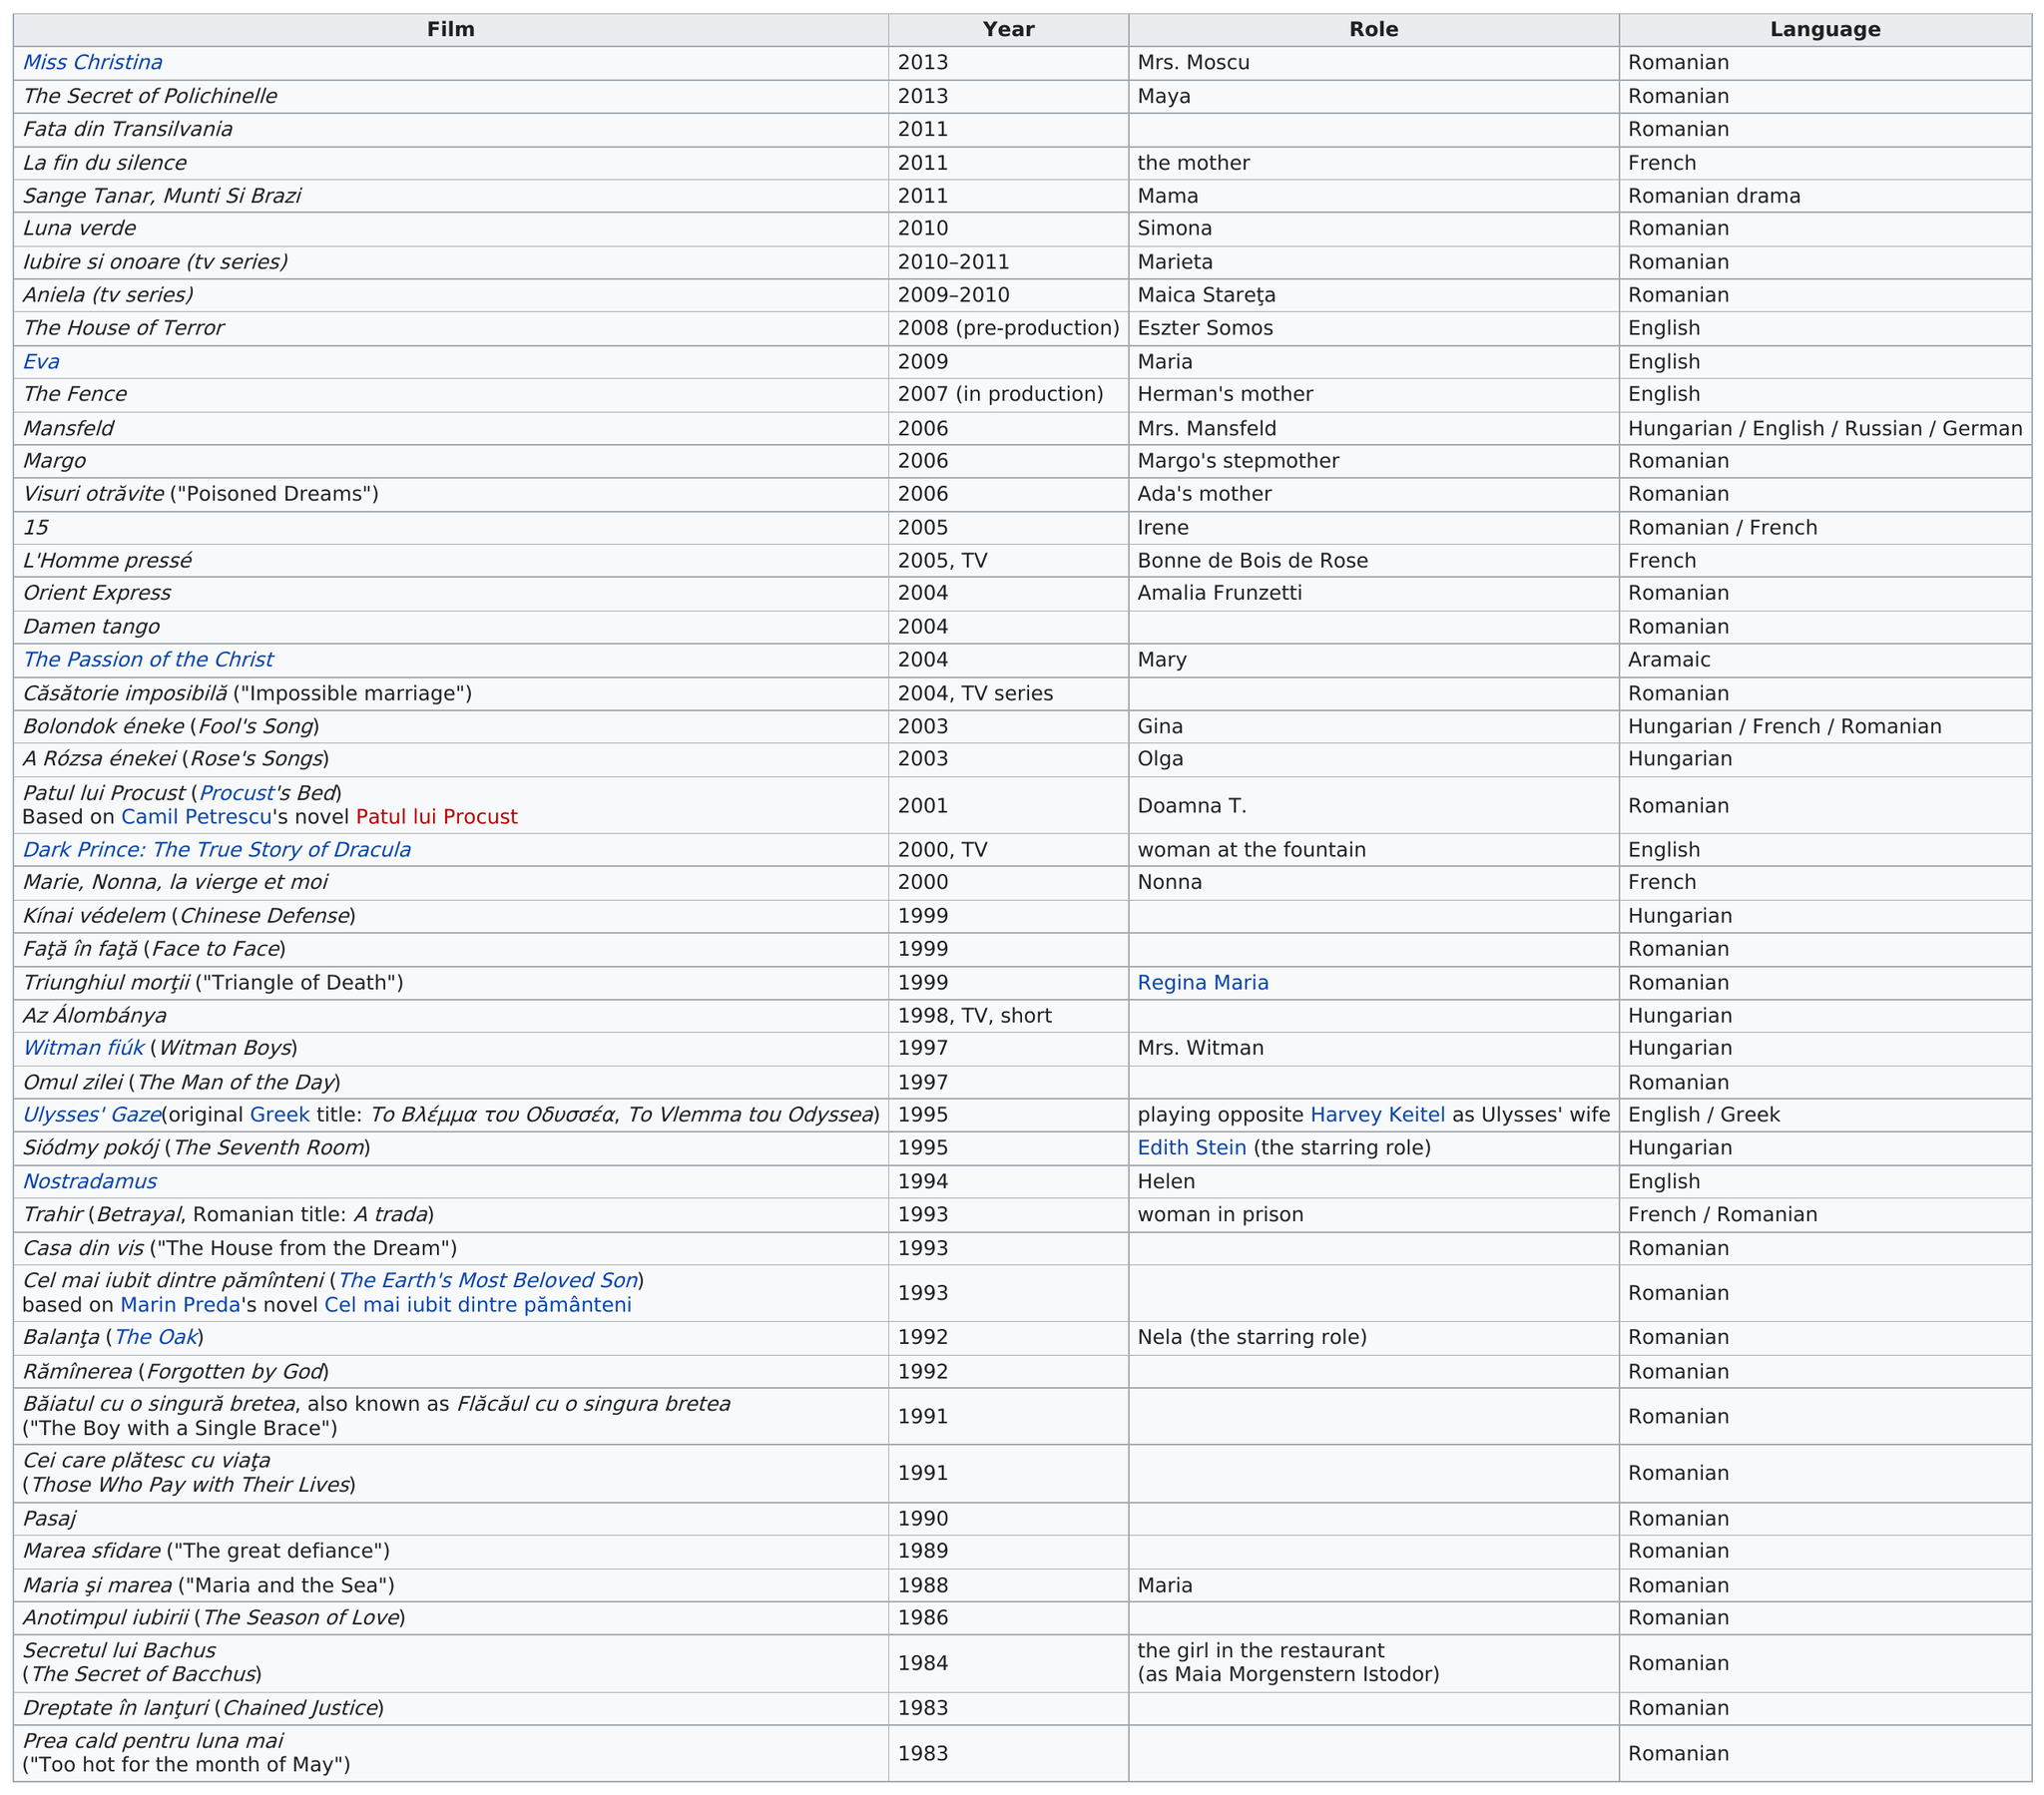Outline some significant characteristics in this image. Morgenstern's film debut was in 1983. 